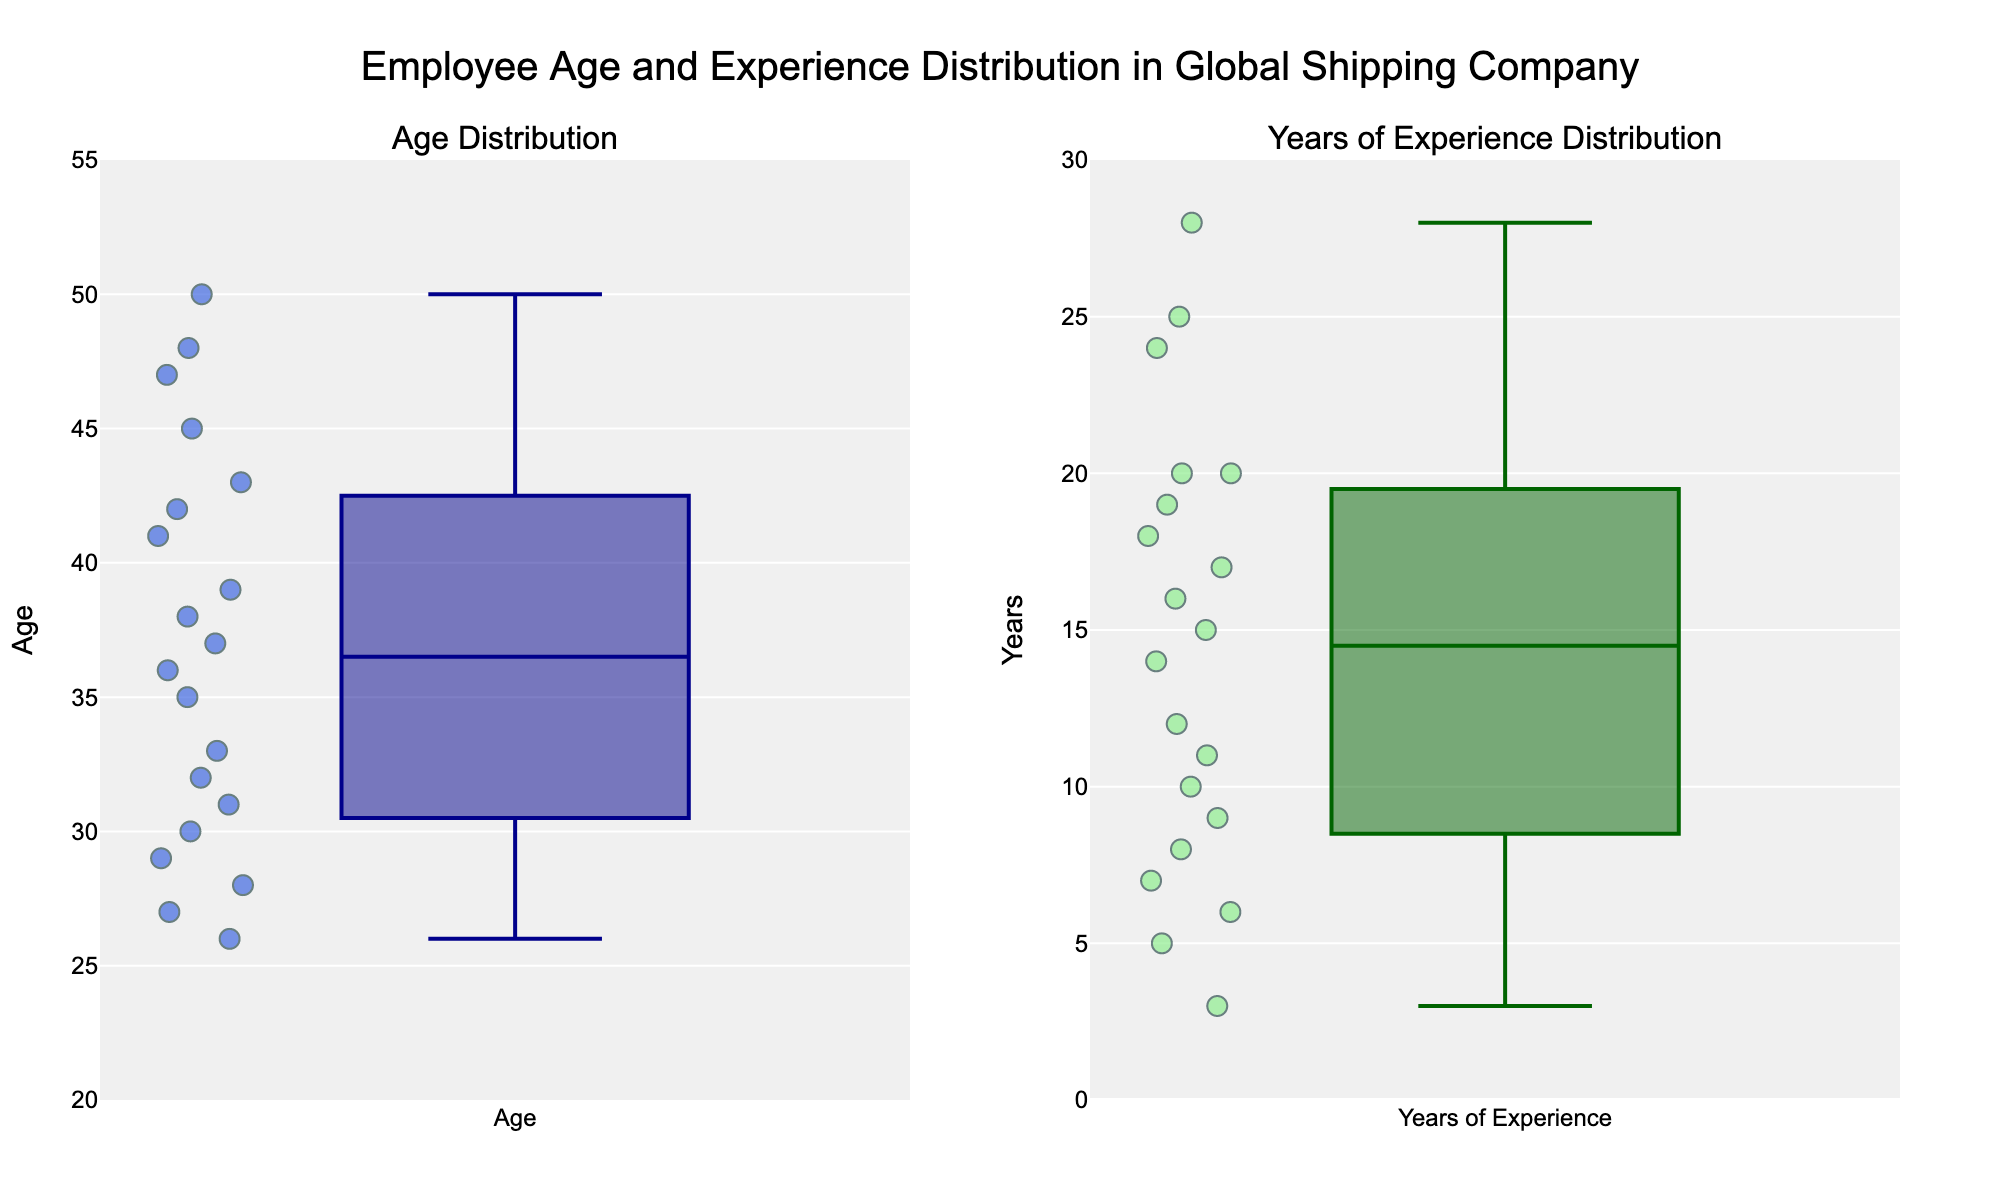What's the title of the plot? The title is located at the top middle of the figure, clearly indicating what the plot represents.
Answer: Employee Age and Experience Distribution in Global Shipping Company How many subplots are there in the figure? The figure is divided into two sections, each showing different distributions.
Answer: 2 In the "Age Distribution" subplot, what is the range of ages displayed on the y-axis? The y-axis range for the Age Distribution subplot can be seen on the left side. It starts at 20 and ends at 55.
Answer: 20 to 55 What color represents the data points for "Years of Experience"? The color of the data points can be observed in the "Years of Experience Distribution" subplot.
Answer: light green How many employees have more than 15 years of experience? By visually counting the data points above the 15 mark in the "Years of Experience Distribution" subplot, we can find the number.
Answer: 7 Who appears to be the youngest employee in the chart? The youngest employee can be identified by finding the lowest data point in the "Age Distribution" subplot.
Answer: Olivia Martinez, 26 Which employee has the most years of experience, and how much is it? We can identify the employee with the highest data point in the "Years of Experience Distribution" subplot.
Answer: Sophia Rossi, 28 years Compare the median age and the median years of experience of the employees. Which one is higher? To find the median, locate the middle point in each subplot. Compare the median age and median years of experience from their respective distributions.
Answer: The median age is higher What is the difference in years between the employee with the highest and the lowest experience? Locate the highest and lowest points in the "Years of Experience Distribution" subplot, and subtract the lowest from the highest.
Answer: 28 - 3 = 25 How many employees are there in total in the dataset? Count all the data points in either subplot as each point represents an employee.
Answer: 20 